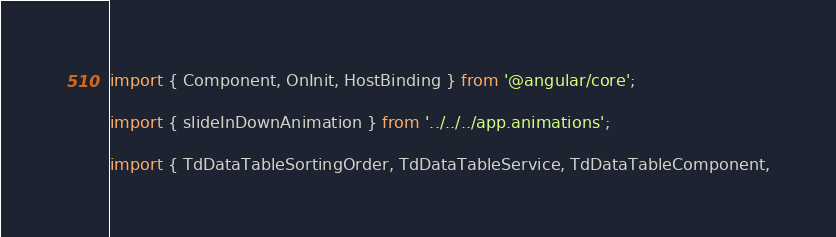Convert code to text. <code><loc_0><loc_0><loc_500><loc_500><_TypeScript_>import { Component, OnInit, HostBinding } from '@angular/core';

import { slideInDownAnimation } from '../../../app.animations';

import { TdDataTableSortingOrder, TdDataTableService, TdDataTableComponent,</code> 